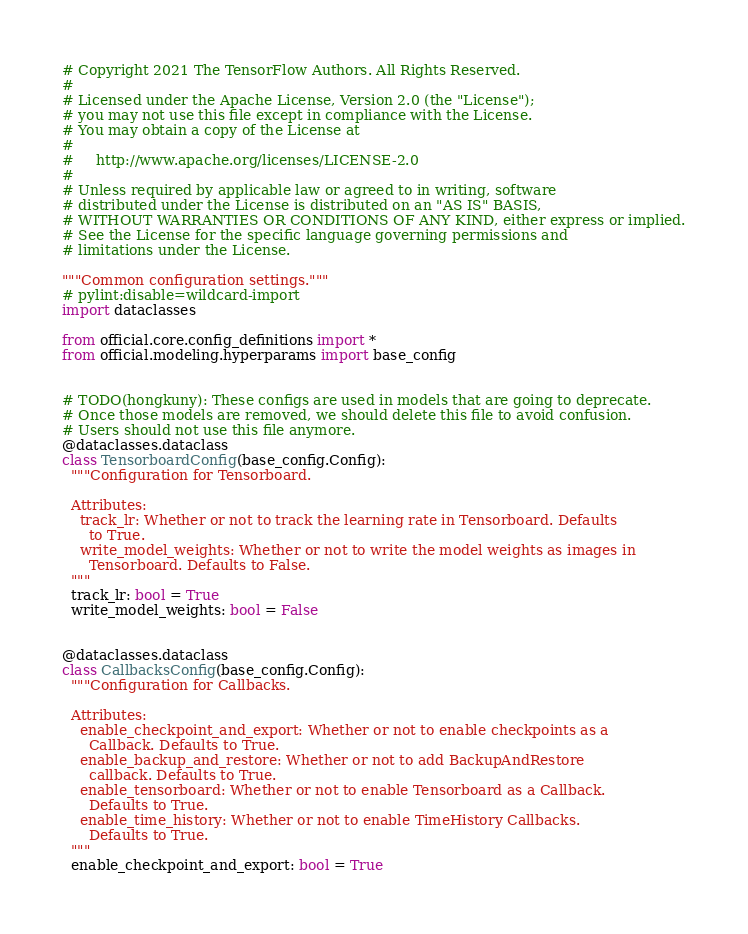Convert code to text. <code><loc_0><loc_0><loc_500><loc_500><_Python_># Copyright 2021 The TensorFlow Authors. All Rights Reserved.
#
# Licensed under the Apache License, Version 2.0 (the "License");
# you may not use this file except in compliance with the License.
# You may obtain a copy of the License at
#
#     http://www.apache.org/licenses/LICENSE-2.0
#
# Unless required by applicable law or agreed to in writing, software
# distributed under the License is distributed on an "AS IS" BASIS,
# WITHOUT WARRANTIES OR CONDITIONS OF ANY KIND, either express or implied.
# See the License for the specific language governing permissions and
# limitations under the License.

"""Common configuration settings."""
# pylint:disable=wildcard-import
import dataclasses

from official.core.config_definitions import *
from official.modeling.hyperparams import base_config


# TODO(hongkuny): These configs are used in models that are going to deprecate.
# Once those models are removed, we should delete this file to avoid confusion.
# Users should not use this file anymore.
@dataclasses.dataclass
class TensorboardConfig(base_config.Config):
  """Configuration for Tensorboard.

  Attributes:
    track_lr: Whether or not to track the learning rate in Tensorboard. Defaults
      to True.
    write_model_weights: Whether or not to write the model weights as images in
      Tensorboard. Defaults to False.
  """
  track_lr: bool = True
  write_model_weights: bool = False


@dataclasses.dataclass
class CallbacksConfig(base_config.Config):
  """Configuration for Callbacks.

  Attributes:
    enable_checkpoint_and_export: Whether or not to enable checkpoints as a
      Callback. Defaults to True.
    enable_backup_and_restore: Whether or not to add BackupAndRestore
      callback. Defaults to True.
    enable_tensorboard: Whether or not to enable Tensorboard as a Callback.
      Defaults to True.
    enable_time_history: Whether or not to enable TimeHistory Callbacks.
      Defaults to True.
  """
  enable_checkpoint_and_export: bool = True</code> 